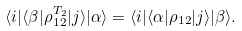<formula> <loc_0><loc_0><loc_500><loc_500>\langle i | \langle \beta | \rho _ { 1 2 } ^ { T _ { 2 } } | j \rangle | \alpha \rangle = \langle i | \langle \alpha | \rho _ { 1 2 } | j \rangle | \beta \rangle .</formula> 